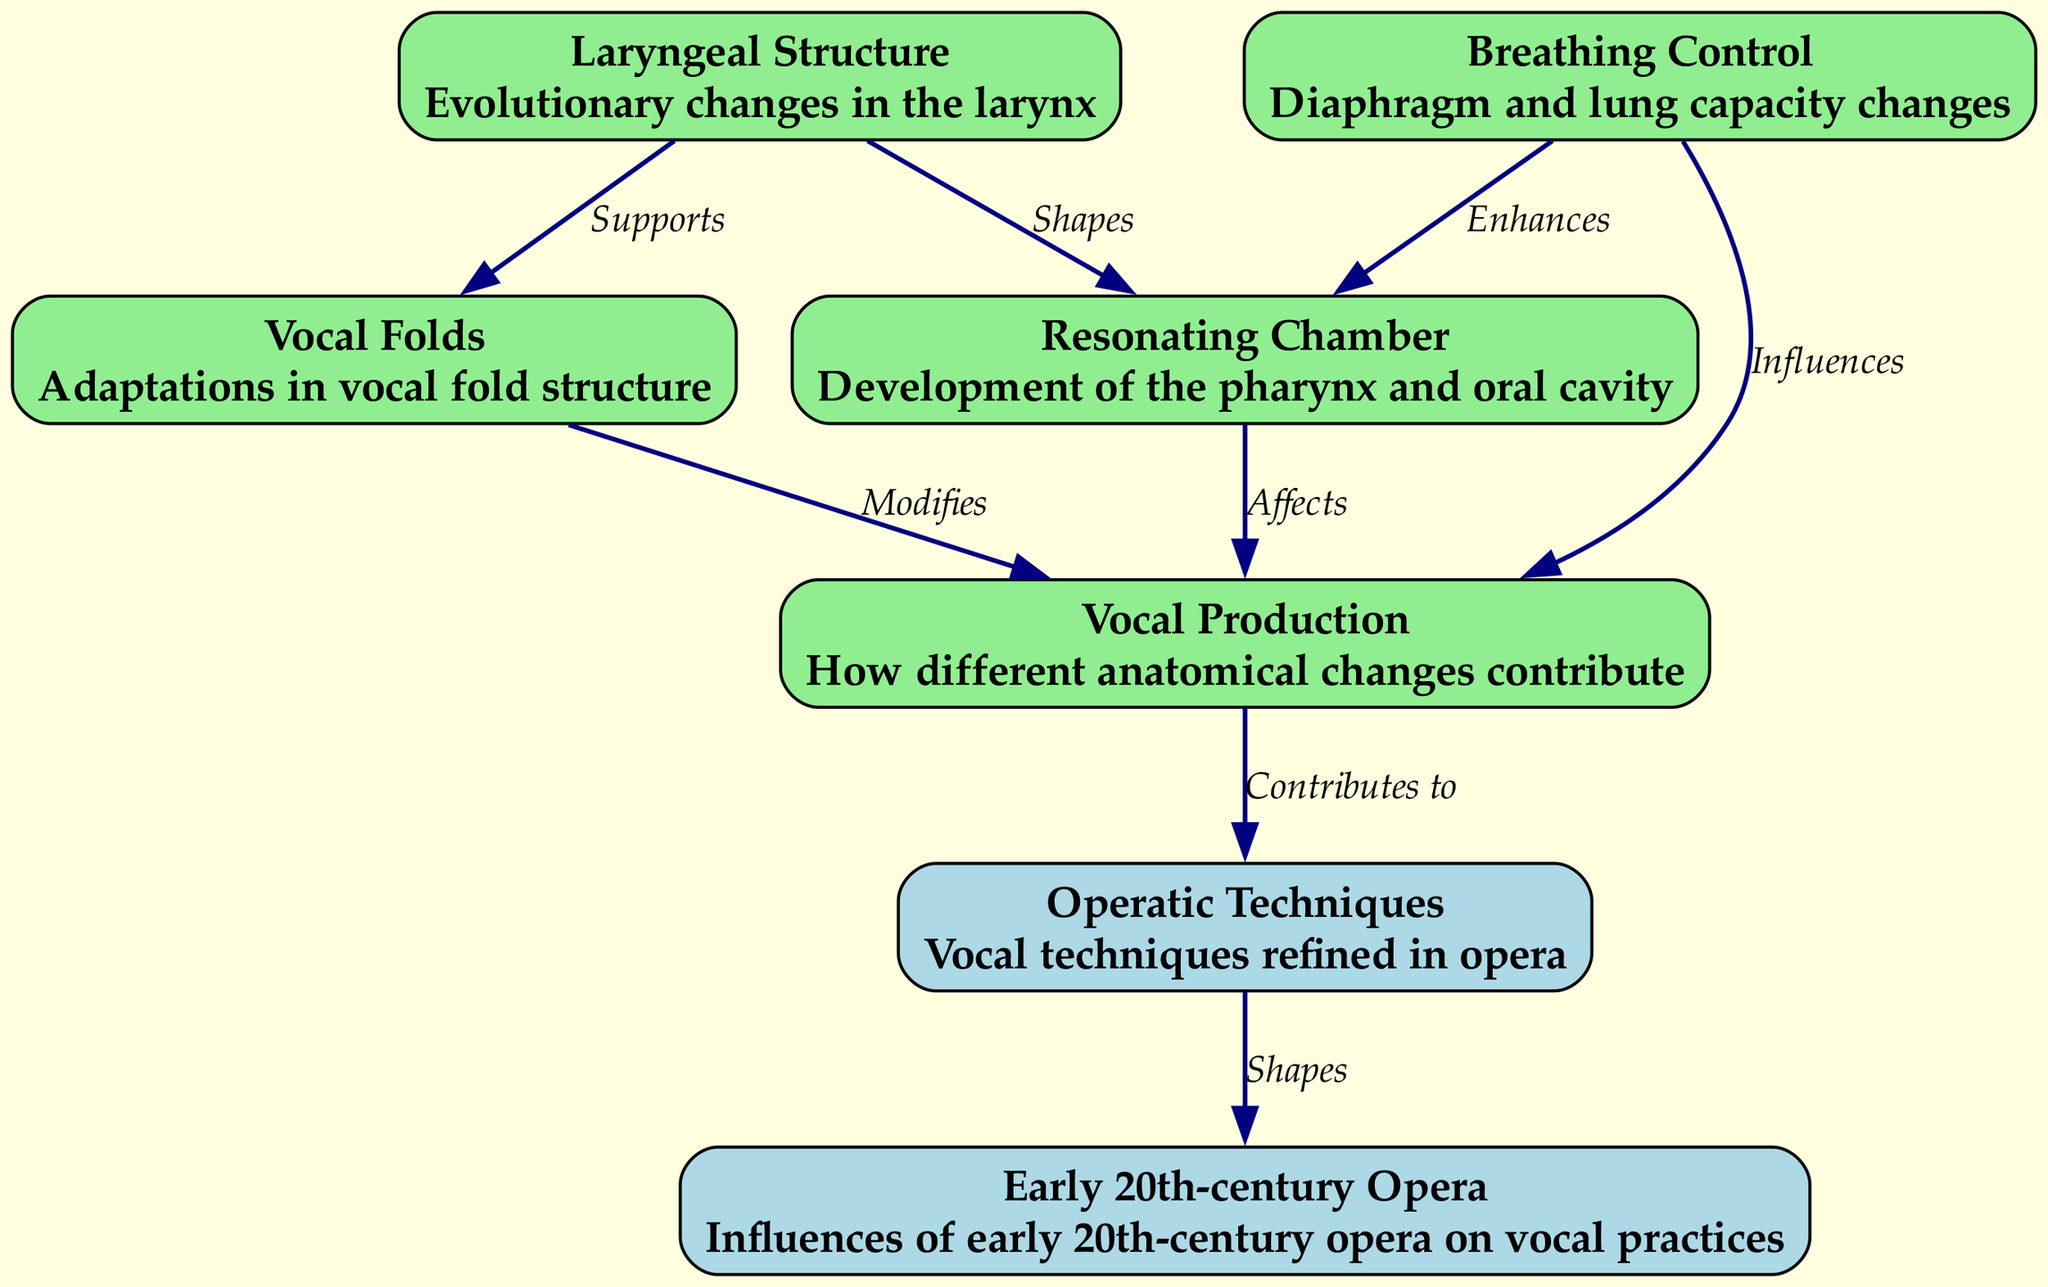What is the total number of nodes in the diagram? By counting the individual nodes listed in the data provided, we have laryngeal structure, vocal folds, resonating chamber, breathing control, vocal production, operatic techniques, and early 20th-century opera, which totals to 7 nodes.
Answer: 7 Which node directly influences vocal production? The edges indicate that both breathing control and vocal folds have a direct influence on vocal production as they have arrows leading to it.
Answer: Breathing control, vocal folds What relationship exists between laryngeal structure and resonating chamber? The edge from laryngeal structure to resonating chamber is labeled "Shapes," indicating that laryngeal structure plays a role in the shaping of the resonating chamber.
Answer: Shapes How many edges connect to the vocal production node? By examining the diagram's edges, we can see that there are three edges leading to the vocal production node from breathing control, vocal folds, and resonating chamber, giving a total of three connections.
Answer: 3 Which node contributes to operatic techniques? The diagram indicates that the vocal production node has a direct contribution to the operatic techniques node, establishing a link of influence.
Answer: Vocal production What type of changes enhance the resonating chamber according to the diagram? The diagram specifies that breathing control enhances the resonating chamber, demonstrating the importance of respiratory changes in the development of vocal capacity.
Answer: Breathing control Explain the connection between early 20th-century opera and operatic techniques. The edge from operatic techniques to early 20th-century opera is labeled "Shapes." This implies that operatic techniques have been influenced and formed by the practices established during the early 20th century in the opera genre.
Answer: Shapes What effect do vocal folds have on vocal production? The edge from vocal folds to vocal production is labeled "Modifies," indicating that adaptations in vocal fold structure specifically make modifications to how vocal production occurs.
Answer: Modifies 